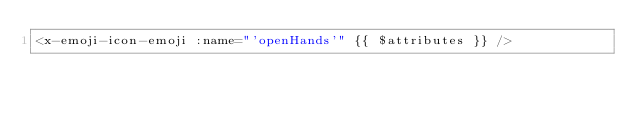Convert code to text. <code><loc_0><loc_0><loc_500><loc_500><_PHP_><x-emoji-icon-emoji :name="'openHands'" {{ $attributes }} />
</code> 